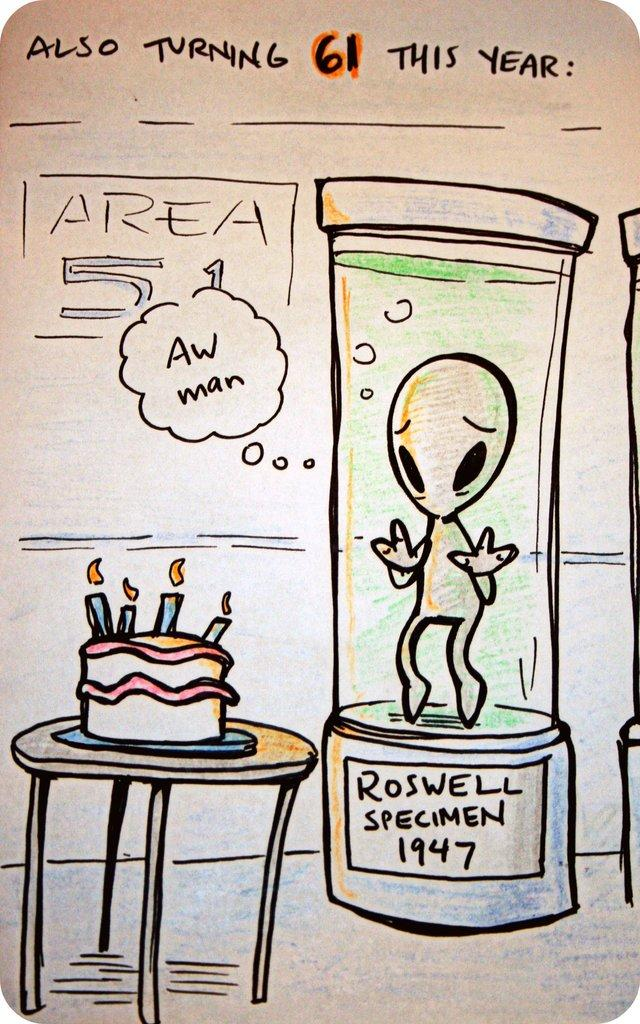What type of visual is the image? The image is a poster. What is the main subject of the poster? There is an alien inside a box in the image. What else can be seen in the image besides the alien? There is a cake on a table in the image. Where is the text located on the poster? The text is at the top of the image. What color is the alien's nose in the image? There is no alien's nose present in the image, as the alien is inside a box. What type of beast can be seen interacting with the cake in the image? There is no beast present in the image; the cake is on a table. 